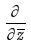<formula> <loc_0><loc_0><loc_500><loc_500>\frac { \partial } { \partial \overline { z } }</formula> 